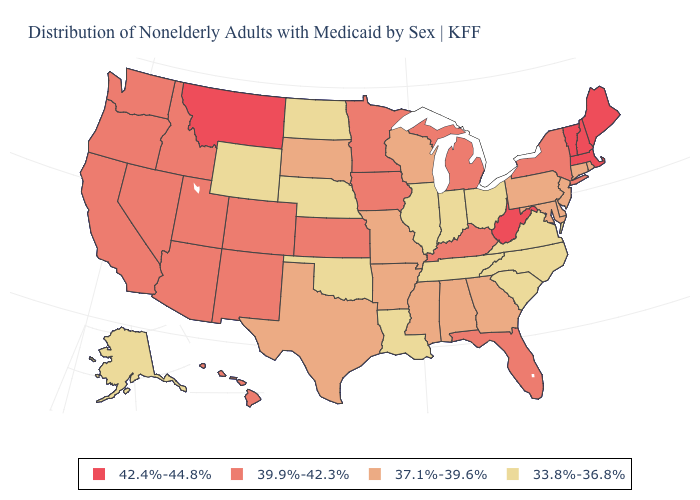Which states have the highest value in the USA?
Give a very brief answer. Maine, Massachusetts, Montana, New Hampshire, Vermont, West Virginia. Does Delaware have the same value as Arkansas?
Give a very brief answer. Yes. What is the value of Iowa?
Keep it brief. 39.9%-42.3%. Name the states that have a value in the range 39.9%-42.3%?
Short answer required. Arizona, California, Colorado, Florida, Hawaii, Idaho, Iowa, Kansas, Kentucky, Michigan, Minnesota, Nevada, New Mexico, New York, Oregon, Utah, Washington. Which states hav the highest value in the West?
Concise answer only. Montana. What is the lowest value in states that border Minnesota?
Write a very short answer. 33.8%-36.8%. Name the states that have a value in the range 42.4%-44.8%?
Give a very brief answer. Maine, Massachusetts, Montana, New Hampshire, Vermont, West Virginia. Name the states that have a value in the range 39.9%-42.3%?
Answer briefly. Arizona, California, Colorado, Florida, Hawaii, Idaho, Iowa, Kansas, Kentucky, Michigan, Minnesota, Nevada, New Mexico, New York, Oregon, Utah, Washington. How many symbols are there in the legend?
Answer briefly. 4. Name the states that have a value in the range 42.4%-44.8%?
Be succinct. Maine, Massachusetts, Montana, New Hampshire, Vermont, West Virginia. What is the highest value in states that border West Virginia?
Short answer required. 39.9%-42.3%. Which states have the lowest value in the South?
Be succinct. Louisiana, North Carolina, Oklahoma, South Carolina, Tennessee, Virginia. Which states hav the highest value in the West?
Quick response, please. Montana. Name the states that have a value in the range 42.4%-44.8%?
Keep it brief. Maine, Massachusetts, Montana, New Hampshire, Vermont, West Virginia. How many symbols are there in the legend?
Quick response, please. 4. 